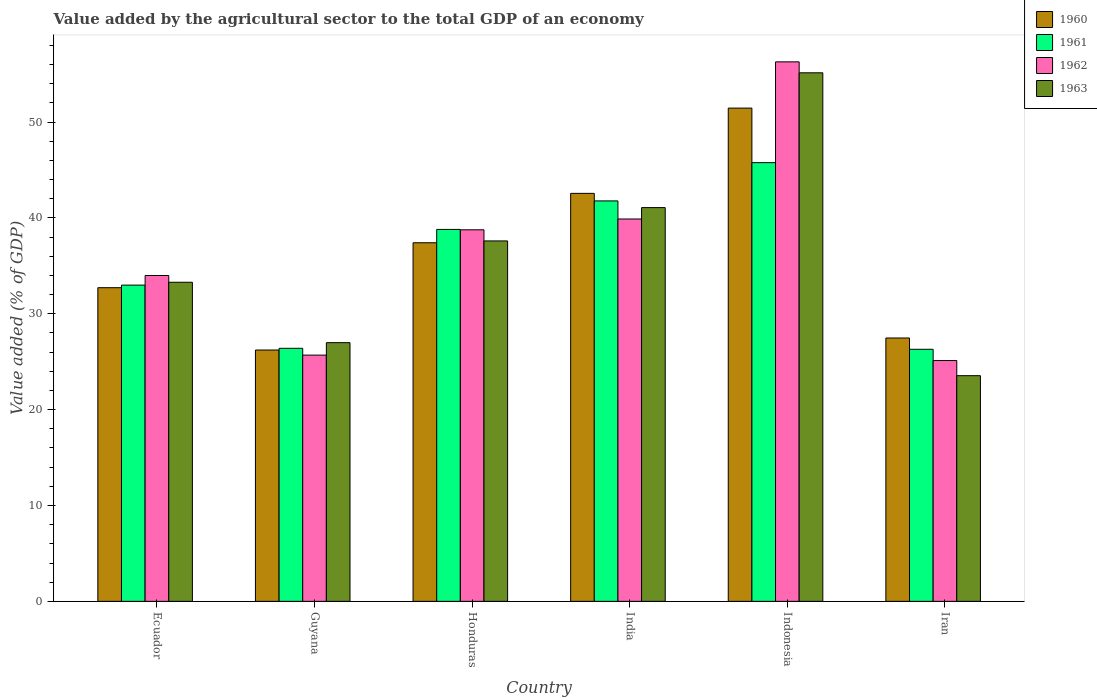How many different coloured bars are there?
Your response must be concise. 4. Are the number of bars on each tick of the X-axis equal?
Offer a terse response. Yes. How many bars are there on the 6th tick from the left?
Ensure brevity in your answer.  4. What is the label of the 3rd group of bars from the left?
Your answer should be very brief. Honduras. What is the value added by the agricultural sector to the total GDP in 1963 in India?
Provide a short and direct response. 41.08. Across all countries, what is the maximum value added by the agricultural sector to the total GDP in 1963?
Your answer should be compact. 55.14. Across all countries, what is the minimum value added by the agricultural sector to the total GDP in 1962?
Your answer should be very brief. 25.12. In which country was the value added by the agricultural sector to the total GDP in 1962 minimum?
Provide a succinct answer. Iran. What is the total value added by the agricultural sector to the total GDP in 1960 in the graph?
Keep it short and to the point. 217.84. What is the difference between the value added by the agricultural sector to the total GDP in 1962 in Guyana and that in India?
Offer a terse response. -14.2. What is the difference between the value added by the agricultural sector to the total GDP in 1960 in Indonesia and the value added by the agricultural sector to the total GDP in 1962 in Iran?
Offer a terse response. 26.34. What is the average value added by the agricultural sector to the total GDP in 1962 per country?
Make the answer very short. 36.62. What is the difference between the value added by the agricultural sector to the total GDP of/in 1961 and value added by the agricultural sector to the total GDP of/in 1960 in Ecuador?
Your answer should be compact. 0.27. What is the ratio of the value added by the agricultural sector to the total GDP in 1961 in Ecuador to that in Guyana?
Your response must be concise. 1.25. What is the difference between the highest and the second highest value added by the agricultural sector to the total GDP in 1961?
Offer a terse response. -3.99. What is the difference between the highest and the lowest value added by the agricultural sector to the total GDP in 1963?
Your response must be concise. 31.6. In how many countries, is the value added by the agricultural sector to the total GDP in 1962 greater than the average value added by the agricultural sector to the total GDP in 1962 taken over all countries?
Give a very brief answer. 3. Is it the case that in every country, the sum of the value added by the agricultural sector to the total GDP in 1960 and value added by the agricultural sector to the total GDP in 1963 is greater than the sum of value added by the agricultural sector to the total GDP in 1961 and value added by the agricultural sector to the total GDP in 1962?
Make the answer very short. No. How many bars are there?
Provide a short and direct response. 24. Are all the bars in the graph horizontal?
Your response must be concise. No. How many countries are there in the graph?
Make the answer very short. 6. What is the difference between two consecutive major ticks on the Y-axis?
Give a very brief answer. 10. Does the graph contain any zero values?
Give a very brief answer. No. Where does the legend appear in the graph?
Keep it short and to the point. Top right. What is the title of the graph?
Keep it short and to the point. Value added by the agricultural sector to the total GDP of an economy. What is the label or title of the X-axis?
Your answer should be compact. Country. What is the label or title of the Y-axis?
Provide a short and direct response. Value added (% of GDP). What is the Value added (% of GDP) in 1960 in Ecuador?
Provide a short and direct response. 32.72. What is the Value added (% of GDP) in 1961 in Ecuador?
Your answer should be very brief. 32.99. What is the Value added (% of GDP) in 1962 in Ecuador?
Offer a terse response. 33.99. What is the Value added (% of GDP) of 1963 in Ecuador?
Keep it short and to the point. 33.29. What is the Value added (% of GDP) of 1960 in Guyana?
Offer a terse response. 26.22. What is the Value added (% of GDP) in 1961 in Guyana?
Your answer should be very brief. 26.4. What is the Value added (% of GDP) of 1962 in Guyana?
Your response must be concise. 25.69. What is the Value added (% of GDP) of 1963 in Guyana?
Ensure brevity in your answer.  26.99. What is the Value added (% of GDP) in 1960 in Honduras?
Keep it short and to the point. 37.41. What is the Value added (% of GDP) of 1961 in Honduras?
Your answer should be compact. 38.8. What is the Value added (% of GDP) of 1962 in Honduras?
Provide a short and direct response. 38.76. What is the Value added (% of GDP) of 1963 in Honduras?
Your answer should be compact. 37.6. What is the Value added (% of GDP) of 1960 in India?
Make the answer very short. 42.56. What is the Value added (% of GDP) of 1961 in India?
Your answer should be very brief. 41.77. What is the Value added (% of GDP) of 1962 in India?
Ensure brevity in your answer.  39.89. What is the Value added (% of GDP) in 1963 in India?
Give a very brief answer. 41.08. What is the Value added (% of GDP) of 1960 in Indonesia?
Offer a terse response. 51.46. What is the Value added (% of GDP) of 1961 in Indonesia?
Your response must be concise. 45.77. What is the Value added (% of GDP) of 1962 in Indonesia?
Keep it short and to the point. 56.28. What is the Value added (% of GDP) of 1963 in Indonesia?
Provide a succinct answer. 55.14. What is the Value added (% of GDP) of 1960 in Iran?
Your answer should be very brief. 27.47. What is the Value added (% of GDP) of 1961 in Iran?
Ensure brevity in your answer.  26.3. What is the Value added (% of GDP) of 1962 in Iran?
Ensure brevity in your answer.  25.12. What is the Value added (% of GDP) of 1963 in Iran?
Your answer should be very brief. 23.54. Across all countries, what is the maximum Value added (% of GDP) in 1960?
Your answer should be very brief. 51.46. Across all countries, what is the maximum Value added (% of GDP) of 1961?
Provide a short and direct response. 45.77. Across all countries, what is the maximum Value added (% of GDP) in 1962?
Offer a terse response. 56.28. Across all countries, what is the maximum Value added (% of GDP) in 1963?
Provide a succinct answer. 55.14. Across all countries, what is the minimum Value added (% of GDP) of 1960?
Keep it short and to the point. 26.22. Across all countries, what is the minimum Value added (% of GDP) in 1961?
Ensure brevity in your answer.  26.3. Across all countries, what is the minimum Value added (% of GDP) in 1962?
Your response must be concise. 25.12. Across all countries, what is the minimum Value added (% of GDP) in 1963?
Offer a terse response. 23.54. What is the total Value added (% of GDP) in 1960 in the graph?
Give a very brief answer. 217.84. What is the total Value added (% of GDP) in 1961 in the graph?
Your response must be concise. 212.02. What is the total Value added (% of GDP) in 1962 in the graph?
Keep it short and to the point. 219.73. What is the total Value added (% of GDP) of 1963 in the graph?
Provide a succinct answer. 217.63. What is the difference between the Value added (% of GDP) in 1960 in Ecuador and that in Guyana?
Your answer should be very brief. 6.5. What is the difference between the Value added (% of GDP) of 1961 in Ecuador and that in Guyana?
Make the answer very short. 6.59. What is the difference between the Value added (% of GDP) in 1962 in Ecuador and that in Guyana?
Your answer should be very brief. 8.31. What is the difference between the Value added (% of GDP) in 1963 in Ecuador and that in Guyana?
Your answer should be very brief. 6.3. What is the difference between the Value added (% of GDP) in 1960 in Ecuador and that in Honduras?
Give a very brief answer. -4.69. What is the difference between the Value added (% of GDP) in 1961 in Ecuador and that in Honduras?
Provide a short and direct response. -5.81. What is the difference between the Value added (% of GDP) in 1962 in Ecuador and that in Honduras?
Give a very brief answer. -4.77. What is the difference between the Value added (% of GDP) in 1963 in Ecuador and that in Honduras?
Keep it short and to the point. -4.31. What is the difference between the Value added (% of GDP) in 1960 in Ecuador and that in India?
Offer a terse response. -9.84. What is the difference between the Value added (% of GDP) of 1961 in Ecuador and that in India?
Keep it short and to the point. -8.78. What is the difference between the Value added (% of GDP) in 1962 in Ecuador and that in India?
Your answer should be very brief. -5.89. What is the difference between the Value added (% of GDP) of 1963 in Ecuador and that in India?
Offer a very short reply. -7.79. What is the difference between the Value added (% of GDP) of 1960 in Ecuador and that in Indonesia?
Offer a very short reply. -18.74. What is the difference between the Value added (% of GDP) in 1961 in Ecuador and that in Indonesia?
Provide a succinct answer. -12.78. What is the difference between the Value added (% of GDP) in 1962 in Ecuador and that in Indonesia?
Provide a short and direct response. -22.29. What is the difference between the Value added (% of GDP) in 1963 in Ecuador and that in Indonesia?
Your response must be concise. -21.85. What is the difference between the Value added (% of GDP) of 1960 in Ecuador and that in Iran?
Ensure brevity in your answer.  5.25. What is the difference between the Value added (% of GDP) in 1961 in Ecuador and that in Iran?
Ensure brevity in your answer.  6.69. What is the difference between the Value added (% of GDP) of 1962 in Ecuador and that in Iran?
Give a very brief answer. 8.87. What is the difference between the Value added (% of GDP) in 1963 in Ecuador and that in Iran?
Your answer should be very brief. 9.74. What is the difference between the Value added (% of GDP) in 1960 in Guyana and that in Honduras?
Give a very brief answer. -11.19. What is the difference between the Value added (% of GDP) in 1961 in Guyana and that in Honduras?
Ensure brevity in your answer.  -12.4. What is the difference between the Value added (% of GDP) in 1962 in Guyana and that in Honduras?
Offer a terse response. -13.07. What is the difference between the Value added (% of GDP) of 1963 in Guyana and that in Honduras?
Ensure brevity in your answer.  -10.61. What is the difference between the Value added (% of GDP) of 1960 in Guyana and that in India?
Your response must be concise. -16.34. What is the difference between the Value added (% of GDP) in 1961 in Guyana and that in India?
Give a very brief answer. -15.38. What is the difference between the Value added (% of GDP) of 1962 in Guyana and that in India?
Your response must be concise. -14.2. What is the difference between the Value added (% of GDP) of 1963 in Guyana and that in India?
Offer a very short reply. -14.09. What is the difference between the Value added (% of GDP) of 1960 in Guyana and that in Indonesia?
Offer a terse response. -25.24. What is the difference between the Value added (% of GDP) of 1961 in Guyana and that in Indonesia?
Ensure brevity in your answer.  -19.37. What is the difference between the Value added (% of GDP) of 1962 in Guyana and that in Indonesia?
Offer a terse response. -30.59. What is the difference between the Value added (% of GDP) in 1963 in Guyana and that in Indonesia?
Give a very brief answer. -28.15. What is the difference between the Value added (% of GDP) of 1960 in Guyana and that in Iran?
Offer a very short reply. -1.25. What is the difference between the Value added (% of GDP) in 1961 in Guyana and that in Iran?
Keep it short and to the point. 0.1. What is the difference between the Value added (% of GDP) in 1962 in Guyana and that in Iran?
Provide a succinct answer. 0.57. What is the difference between the Value added (% of GDP) of 1963 in Guyana and that in Iran?
Your answer should be compact. 3.44. What is the difference between the Value added (% of GDP) of 1960 in Honduras and that in India?
Provide a short and direct response. -5.15. What is the difference between the Value added (% of GDP) in 1961 in Honduras and that in India?
Your answer should be very brief. -2.97. What is the difference between the Value added (% of GDP) in 1962 in Honduras and that in India?
Your response must be concise. -1.13. What is the difference between the Value added (% of GDP) of 1963 in Honduras and that in India?
Offer a terse response. -3.48. What is the difference between the Value added (% of GDP) in 1960 in Honduras and that in Indonesia?
Ensure brevity in your answer.  -14.05. What is the difference between the Value added (% of GDP) of 1961 in Honduras and that in Indonesia?
Your answer should be very brief. -6.96. What is the difference between the Value added (% of GDP) in 1962 in Honduras and that in Indonesia?
Keep it short and to the point. -17.52. What is the difference between the Value added (% of GDP) in 1963 in Honduras and that in Indonesia?
Offer a very short reply. -17.54. What is the difference between the Value added (% of GDP) of 1960 in Honduras and that in Iran?
Keep it short and to the point. 9.94. What is the difference between the Value added (% of GDP) in 1961 in Honduras and that in Iran?
Provide a short and direct response. 12.51. What is the difference between the Value added (% of GDP) of 1962 in Honduras and that in Iran?
Offer a very short reply. 13.64. What is the difference between the Value added (% of GDP) of 1963 in Honduras and that in Iran?
Your answer should be very brief. 14.06. What is the difference between the Value added (% of GDP) in 1960 in India and that in Indonesia?
Provide a short and direct response. -8.9. What is the difference between the Value added (% of GDP) in 1961 in India and that in Indonesia?
Give a very brief answer. -3.99. What is the difference between the Value added (% of GDP) in 1962 in India and that in Indonesia?
Make the answer very short. -16.39. What is the difference between the Value added (% of GDP) of 1963 in India and that in Indonesia?
Provide a short and direct response. -14.06. What is the difference between the Value added (% of GDP) of 1960 in India and that in Iran?
Offer a terse response. 15.09. What is the difference between the Value added (% of GDP) in 1961 in India and that in Iran?
Offer a very short reply. 15.48. What is the difference between the Value added (% of GDP) in 1962 in India and that in Iran?
Your answer should be very brief. 14.77. What is the difference between the Value added (% of GDP) in 1963 in India and that in Iran?
Your answer should be compact. 17.53. What is the difference between the Value added (% of GDP) of 1960 in Indonesia and that in Iran?
Your answer should be very brief. 23.98. What is the difference between the Value added (% of GDP) of 1961 in Indonesia and that in Iran?
Offer a very short reply. 19.47. What is the difference between the Value added (% of GDP) of 1962 in Indonesia and that in Iran?
Provide a short and direct response. 31.16. What is the difference between the Value added (% of GDP) in 1963 in Indonesia and that in Iran?
Provide a short and direct response. 31.6. What is the difference between the Value added (% of GDP) of 1960 in Ecuador and the Value added (% of GDP) of 1961 in Guyana?
Give a very brief answer. 6.32. What is the difference between the Value added (% of GDP) in 1960 in Ecuador and the Value added (% of GDP) in 1962 in Guyana?
Your response must be concise. 7.03. What is the difference between the Value added (% of GDP) of 1960 in Ecuador and the Value added (% of GDP) of 1963 in Guyana?
Your answer should be compact. 5.73. What is the difference between the Value added (% of GDP) of 1961 in Ecuador and the Value added (% of GDP) of 1962 in Guyana?
Make the answer very short. 7.3. What is the difference between the Value added (% of GDP) in 1961 in Ecuador and the Value added (% of GDP) in 1963 in Guyana?
Provide a succinct answer. 6. What is the difference between the Value added (% of GDP) of 1962 in Ecuador and the Value added (% of GDP) of 1963 in Guyana?
Your answer should be very brief. 7.01. What is the difference between the Value added (% of GDP) in 1960 in Ecuador and the Value added (% of GDP) in 1961 in Honduras?
Make the answer very short. -6.08. What is the difference between the Value added (% of GDP) of 1960 in Ecuador and the Value added (% of GDP) of 1962 in Honduras?
Provide a succinct answer. -6.04. What is the difference between the Value added (% of GDP) of 1960 in Ecuador and the Value added (% of GDP) of 1963 in Honduras?
Keep it short and to the point. -4.88. What is the difference between the Value added (% of GDP) in 1961 in Ecuador and the Value added (% of GDP) in 1962 in Honduras?
Provide a short and direct response. -5.77. What is the difference between the Value added (% of GDP) of 1961 in Ecuador and the Value added (% of GDP) of 1963 in Honduras?
Offer a terse response. -4.61. What is the difference between the Value added (% of GDP) of 1962 in Ecuador and the Value added (% of GDP) of 1963 in Honduras?
Offer a very short reply. -3.61. What is the difference between the Value added (% of GDP) of 1960 in Ecuador and the Value added (% of GDP) of 1961 in India?
Offer a very short reply. -9.05. What is the difference between the Value added (% of GDP) in 1960 in Ecuador and the Value added (% of GDP) in 1962 in India?
Offer a terse response. -7.17. What is the difference between the Value added (% of GDP) of 1960 in Ecuador and the Value added (% of GDP) of 1963 in India?
Keep it short and to the point. -8.36. What is the difference between the Value added (% of GDP) in 1961 in Ecuador and the Value added (% of GDP) in 1962 in India?
Offer a very short reply. -6.9. What is the difference between the Value added (% of GDP) of 1961 in Ecuador and the Value added (% of GDP) of 1963 in India?
Ensure brevity in your answer.  -8.09. What is the difference between the Value added (% of GDP) in 1962 in Ecuador and the Value added (% of GDP) in 1963 in India?
Your response must be concise. -7.08. What is the difference between the Value added (% of GDP) in 1960 in Ecuador and the Value added (% of GDP) in 1961 in Indonesia?
Provide a succinct answer. -13.05. What is the difference between the Value added (% of GDP) of 1960 in Ecuador and the Value added (% of GDP) of 1962 in Indonesia?
Give a very brief answer. -23.56. What is the difference between the Value added (% of GDP) in 1960 in Ecuador and the Value added (% of GDP) in 1963 in Indonesia?
Ensure brevity in your answer.  -22.42. What is the difference between the Value added (% of GDP) of 1961 in Ecuador and the Value added (% of GDP) of 1962 in Indonesia?
Your answer should be very brief. -23.29. What is the difference between the Value added (% of GDP) of 1961 in Ecuador and the Value added (% of GDP) of 1963 in Indonesia?
Make the answer very short. -22.15. What is the difference between the Value added (% of GDP) in 1962 in Ecuador and the Value added (% of GDP) in 1963 in Indonesia?
Keep it short and to the point. -21.14. What is the difference between the Value added (% of GDP) in 1960 in Ecuador and the Value added (% of GDP) in 1961 in Iran?
Your answer should be very brief. 6.43. What is the difference between the Value added (% of GDP) in 1960 in Ecuador and the Value added (% of GDP) in 1962 in Iran?
Provide a succinct answer. 7.6. What is the difference between the Value added (% of GDP) of 1960 in Ecuador and the Value added (% of GDP) of 1963 in Iran?
Give a very brief answer. 9.18. What is the difference between the Value added (% of GDP) of 1961 in Ecuador and the Value added (% of GDP) of 1962 in Iran?
Your response must be concise. 7.87. What is the difference between the Value added (% of GDP) in 1961 in Ecuador and the Value added (% of GDP) in 1963 in Iran?
Your response must be concise. 9.45. What is the difference between the Value added (% of GDP) of 1962 in Ecuador and the Value added (% of GDP) of 1963 in Iran?
Provide a short and direct response. 10.45. What is the difference between the Value added (% of GDP) in 1960 in Guyana and the Value added (% of GDP) in 1961 in Honduras?
Your response must be concise. -12.58. What is the difference between the Value added (% of GDP) of 1960 in Guyana and the Value added (% of GDP) of 1962 in Honduras?
Keep it short and to the point. -12.54. What is the difference between the Value added (% of GDP) of 1960 in Guyana and the Value added (% of GDP) of 1963 in Honduras?
Offer a very short reply. -11.38. What is the difference between the Value added (% of GDP) of 1961 in Guyana and the Value added (% of GDP) of 1962 in Honduras?
Give a very brief answer. -12.36. What is the difference between the Value added (% of GDP) in 1961 in Guyana and the Value added (% of GDP) in 1963 in Honduras?
Provide a succinct answer. -11.2. What is the difference between the Value added (% of GDP) in 1962 in Guyana and the Value added (% of GDP) in 1963 in Honduras?
Provide a short and direct response. -11.91. What is the difference between the Value added (% of GDP) of 1960 in Guyana and the Value added (% of GDP) of 1961 in India?
Offer a very short reply. -15.55. What is the difference between the Value added (% of GDP) in 1960 in Guyana and the Value added (% of GDP) in 1962 in India?
Your answer should be very brief. -13.67. What is the difference between the Value added (% of GDP) in 1960 in Guyana and the Value added (% of GDP) in 1963 in India?
Give a very brief answer. -14.86. What is the difference between the Value added (% of GDP) of 1961 in Guyana and the Value added (% of GDP) of 1962 in India?
Keep it short and to the point. -13.49. What is the difference between the Value added (% of GDP) in 1961 in Guyana and the Value added (% of GDP) in 1963 in India?
Your answer should be compact. -14.68. What is the difference between the Value added (% of GDP) of 1962 in Guyana and the Value added (% of GDP) of 1963 in India?
Provide a succinct answer. -15.39. What is the difference between the Value added (% of GDP) of 1960 in Guyana and the Value added (% of GDP) of 1961 in Indonesia?
Offer a very short reply. -19.55. What is the difference between the Value added (% of GDP) of 1960 in Guyana and the Value added (% of GDP) of 1962 in Indonesia?
Give a very brief answer. -30.06. What is the difference between the Value added (% of GDP) in 1960 in Guyana and the Value added (% of GDP) in 1963 in Indonesia?
Make the answer very short. -28.92. What is the difference between the Value added (% of GDP) of 1961 in Guyana and the Value added (% of GDP) of 1962 in Indonesia?
Your response must be concise. -29.88. What is the difference between the Value added (% of GDP) in 1961 in Guyana and the Value added (% of GDP) in 1963 in Indonesia?
Your answer should be very brief. -28.74. What is the difference between the Value added (% of GDP) in 1962 in Guyana and the Value added (% of GDP) in 1963 in Indonesia?
Provide a short and direct response. -29.45. What is the difference between the Value added (% of GDP) of 1960 in Guyana and the Value added (% of GDP) of 1961 in Iran?
Ensure brevity in your answer.  -0.08. What is the difference between the Value added (% of GDP) in 1960 in Guyana and the Value added (% of GDP) in 1962 in Iran?
Keep it short and to the point. 1.1. What is the difference between the Value added (% of GDP) in 1960 in Guyana and the Value added (% of GDP) in 1963 in Iran?
Keep it short and to the point. 2.68. What is the difference between the Value added (% of GDP) of 1961 in Guyana and the Value added (% of GDP) of 1962 in Iran?
Keep it short and to the point. 1.28. What is the difference between the Value added (% of GDP) in 1961 in Guyana and the Value added (% of GDP) in 1963 in Iran?
Keep it short and to the point. 2.85. What is the difference between the Value added (% of GDP) in 1962 in Guyana and the Value added (% of GDP) in 1963 in Iran?
Keep it short and to the point. 2.15. What is the difference between the Value added (% of GDP) in 1960 in Honduras and the Value added (% of GDP) in 1961 in India?
Your answer should be very brief. -4.36. What is the difference between the Value added (% of GDP) of 1960 in Honduras and the Value added (% of GDP) of 1962 in India?
Provide a succinct answer. -2.48. What is the difference between the Value added (% of GDP) of 1960 in Honduras and the Value added (% of GDP) of 1963 in India?
Your answer should be compact. -3.67. What is the difference between the Value added (% of GDP) of 1961 in Honduras and the Value added (% of GDP) of 1962 in India?
Your answer should be compact. -1.09. What is the difference between the Value added (% of GDP) in 1961 in Honduras and the Value added (% of GDP) in 1963 in India?
Ensure brevity in your answer.  -2.27. What is the difference between the Value added (% of GDP) in 1962 in Honduras and the Value added (% of GDP) in 1963 in India?
Your answer should be compact. -2.32. What is the difference between the Value added (% of GDP) in 1960 in Honduras and the Value added (% of GDP) in 1961 in Indonesia?
Offer a terse response. -8.36. What is the difference between the Value added (% of GDP) of 1960 in Honduras and the Value added (% of GDP) of 1962 in Indonesia?
Offer a very short reply. -18.87. What is the difference between the Value added (% of GDP) in 1960 in Honduras and the Value added (% of GDP) in 1963 in Indonesia?
Offer a very short reply. -17.73. What is the difference between the Value added (% of GDP) in 1961 in Honduras and the Value added (% of GDP) in 1962 in Indonesia?
Your answer should be compact. -17.48. What is the difference between the Value added (% of GDP) in 1961 in Honduras and the Value added (% of GDP) in 1963 in Indonesia?
Make the answer very short. -16.34. What is the difference between the Value added (% of GDP) of 1962 in Honduras and the Value added (% of GDP) of 1963 in Indonesia?
Offer a terse response. -16.38. What is the difference between the Value added (% of GDP) of 1960 in Honduras and the Value added (% of GDP) of 1961 in Iran?
Make the answer very short. 11.11. What is the difference between the Value added (% of GDP) in 1960 in Honduras and the Value added (% of GDP) in 1962 in Iran?
Make the answer very short. 12.29. What is the difference between the Value added (% of GDP) in 1960 in Honduras and the Value added (% of GDP) in 1963 in Iran?
Your response must be concise. 13.87. What is the difference between the Value added (% of GDP) in 1961 in Honduras and the Value added (% of GDP) in 1962 in Iran?
Keep it short and to the point. 13.68. What is the difference between the Value added (% of GDP) of 1961 in Honduras and the Value added (% of GDP) of 1963 in Iran?
Ensure brevity in your answer.  15.26. What is the difference between the Value added (% of GDP) in 1962 in Honduras and the Value added (% of GDP) in 1963 in Iran?
Offer a very short reply. 15.22. What is the difference between the Value added (% of GDP) in 1960 in India and the Value added (% of GDP) in 1961 in Indonesia?
Make the answer very short. -3.21. What is the difference between the Value added (% of GDP) of 1960 in India and the Value added (% of GDP) of 1962 in Indonesia?
Give a very brief answer. -13.72. What is the difference between the Value added (% of GDP) of 1960 in India and the Value added (% of GDP) of 1963 in Indonesia?
Your answer should be very brief. -12.58. What is the difference between the Value added (% of GDP) of 1961 in India and the Value added (% of GDP) of 1962 in Indonesia?
Offer a terse response. -14.51. What is the difference between the Value added (% of GDP) of 1961 in India and the Value added (% of GDP) of 1963 in Indonesia?
Ensure brevity in your answer.  -13.36. What is the difference between the Value added (% of GDP) of 1962 in India and the Value added (% of GDP) of 1963 in Indonesia?
Your answer should be compact. -15.25. What is the difference between the Value added (% of GDP) of 1960 in India and the Value added (% of GDP) of 1961 in Iran?
Your answer should be compact. 16.27. What is the difference between the Value added (% of GDP) in 1960 in India and the Value added (% of GDP) in 1962 in Iran?
Provide a succinct answer. 17.44. What is the difference between the Value added (% of GDP) in 1960 in India and the Value added (% of GDP) in 1963 in Iran?
Your response must be concise. 19.02. What is the difference between the Value added (% of GDP) in 1961 in India and the Value added (% of GDP) in 1962 in Iran?
Keep it short and to the point. 16.65. What is the difference between the Value added (% of GDP) of 1961 in India and the Value added (% of GDP) of 1963 in Iran?
Offer a terse response. 18.23. What is the difference between the Value added (% of GDP) of 1962 in India and the Value added (% of GDP) of 1963 in Iran?
Your response must be concise. 16.35. What is the difference between the Value added (% of GDP) of 1960 in Indonesia and the Value added (% of GDP) of 1961 in Iran?
Make the answer very short. 25.16. What is the difference between the Value added (% of GDP) of 1960 in Indonesia and the Value added (% of GDP) of 1962 in Iran?
Give a very brief answer. 26.34. What is the difference between the Value added (% of GDP) in 1960 in Indonesia and the Value added (% of GDP) in 1963 in Iran?
Make the answer very short. 27.91. What is the difference between the Value added (% of GDP) in 1961 in Indonesia and the Value added (% of GDP) in 1962 in Iran?
Ensure brevity in your answer.  20.65. What is the difference between the Value added (% of GDP) in 1961 in Indonesia and the Value added (% of GDP) in 1963 in Iran?
Offer a terse response. 22.22. What is the difference between the Value added (% of GDP) of 1962 in Indonesia and the Value added (% of GDP) of 1963 in Iran?
Ensure brevity in your answer.  32.74. What is the average Value added (% of GDP) in 1960 per country?
Your answer should be compact. 36.31. What is the average Value added (% of GDP) of 1961 per country?
Your answer should be compact. 35.34. What is the average Value added (% of GDP) in 1962 per country?
Your answer should be compact. 36.62. What is the average Value added (% of GDP) in 1963 per country?
Provide a short and direct response. 36.27. What is the difference between the Value added (% of GDP) of 1960 and Value added (% of GDP) of 1961 in Ecuador?
Provide a short and direct response. -0.27. What is the difference between the Value added (% of GDP) of 1960 and Value added (% of GDP) of 1962 in Ecuador?
Offer a very short reply. -1.27. What is the difference between the Value added (% of GDP) of 1960 and Value added (% of GDP) of 1963 in Ecuador?
Ensure brevity in your answer.  -0.57. What is the difference between the Value added (% of GDP) in 1961 and Value added (% of GDP) in 1962 in Ecuador?
Offer a terse response. -1. What is the difference between the Value added (% of GDP) of 1961 and Value added (% of GDP) of 1963 in Ecuador?
Ensure brevity in your answer.  -0.3. What is the difference between the Value added (% of GDP) in 1962 and Value added (% of GDP) in 1963 in Ecuador?
Offer a very short reply. 0.71. What is the difference between the Value added (% of GDP) in 1960 and Value added (% of GDP) in 1961 in Guyana?
Offer a very short reply. -0.18. What is the difference between the Value added (% of GDP) of 1960 and Value added (% of GDP) of 1962 in Guyana?
Your response must be concise. 0.53. What is the difference between the Value added (% of GDP) of 1960 and Value added (% of GDP) of 1963 in Guyana?
Your response must be concise. -0.77. What is the difference between the Value added (% of GDP) in 1961 and Value added (% of GDP) in 1962 in Guyana?
Ensure brevity in your answer.  0.71. What is the difference between the Value added (% of GDP) of 1961 and Value added (% of GDP) of 1963 in Guyana?
Provide a succinct answer. -0.59. What is the difference between the Value added (% of GDP) of 1962 and Value added (% of GDP) of 1963 in Guyana?
Provide a short and direct response. -1.3. What is the difference between the Value added (% of GDP) in 1960 and Value added (% of GDP) in 1961 in Honduras?
Your answer should be very brief. -1.39. What is the difference between the Value added (% of GDP) in 1960 and Value added (% of GDP) in 1962 in Honduras?
Your answer should be compact. -1.35. What is the difference between the Value added (% of GDP) of 1960 and Value added (% of GDP) of 1963 in Honduras?
Ensure brevity in your answer.  -0.19. What is the difference between the Value added (% of GDP) of 1961 and Value added (% of GDP) of 1962 in Honduras?
Provide a short and direct response. 0.04. What is the difference between the Value added (% of GDP) of 1961 and Value added (% of GDP) of 1963 in Honduras?
Provide a succinct answer. 1.2. What is the difference between the Value added (% of GDP) of 1962 and Value added (% of GDP) of 1963 in Honduras?
Make the answer very short. 1.16. What is the difference between the Value added (% of GDP) of 1960 and Value added (% of GDP) of 1961 in India?
Give a very brief answer. 0.79. What is the difference between the Value added (% of GDP) of 1960 and Value added (% of GDP) of 1962 in India?
Your answer should be very brief. 2.67. What is the difference between the Value added (% of GDP) in 1960 and Value added (% of GDP) in 1963 in India?
Your answer should be very brief. 1.49. What is the difference between the Value added (% of GDP) of 1961 and Value added (% of GDP) of 1962 in India?
Your response must be concise. 1.89. What is the difference between the Value added (% of GDP) of 1961 and Value added (% of GDP) of 1963 in India?
Keep it short and to the point. 0.7. What is the difference between the Value added (% of GDP) in 1962 and Value added (% of GDP) in 1963 in India?
Your response must be concise. -1.19. What is the difference between the Value added (% of GDP) of 1960 and Value added (% of GDP) of 1961 in Indonesia?
Ensure brevity in your answer.  5.69. What is the difference between the Value added (% of GDP) of 1960 and Value added (% of GDP) of 1962 in Indonesia?
Your answer should be compact. -4.82. What is the difference between the Value added (% of GDP) in 1960 and Value added (% of GDP) in 1963 in Indonesia?
Offer a terse response. -3.68. What is the difference between the Value added (% of GDP) of 1961 and Value added (% of GDP) of 1962 in Indonesia?
Your answer should be very brief. -10.51. What is the difference between the Value added (% of GDP) of 1961 and Value added (% of GDP) of 1963 in Indonesia?
Give a very brief answer. -9.37. What is the difference between the Value added (% of GDP) of 1962 and Value added (% of GDP) of 1963 in Indonesia?
Your answer should be very brief. 1.14. What is the difference between the Value added (% of GDP) of 1960 and Value added (% of GDP) of 1961 in Iran?
Provide a short and direct response. 1.18. What is the difference between the Value added (% of GDP) in 1960 and Value added (% of GDP) in 1962 in Iran?
Ensure brevity in your answer.  2.35. What is the difference between the Value added (% of GDP) of 1960 and Value added (% of GDP) of 1963 in Iran?
Offer a very short reply. 3.93. What is the difference between the Value added (% of GDP) in 1961 and Value added (% of GDP) in 1962 in Iran?
Keep it short and to the point. 1.17. What is the difference between the Value added (% of GDP) of 1961 and Value added (% of GDP) of 1963 in Iran?
Your answer should be compact. 2.75. What is the difference between the Value added (% of GDP) in 1962 and Value added (% of GDP) in 1963 in Iran?
Offer a very short reply. 1.58. What is the ratio of the Value added (% of GDP) of 1960 in Ecuador to that in Guyana?
Keep it short and to the point. 1.25. What is the ratio of the Value added (% of GDP) of 1961 in Ecuador to that in Guyana?
Ensure brevity in your answer.  1.25. What is the ratio of the Value added (% of GDP) in 1962 in Ecuador to that in Guyana?
Offer a terse response. 1.32. What is the ratio of the Value added (% of GDP) of 1963 in Ecuador to that in Guyana?
Provide a succinct answer. 1.23. What is the ratio of the Value added (% of GDP) in 1960 in Ecuador to that in Honduras?
Make the answer very short. 0.87. What is the ratio of the Value added (% of GDP) in 1961 in Ecuador to that in Honduras?
Provide a succinct answer. 0.85. What is the ratio of the Value added (% of GDP) of 1962 in Ecuador to that in Honduras?
Provide a short and direct response. 0.88. What is the ratio of the Value added (% of GDP) of 1963 in Ecuador to that in Honduras?
Your response must be concise. 0.89. What is the ratio of the Value added (% of GDP) of 1960 in Ecuador to that in India?
Keep it short and to the point. 0.77. What is the ratio of the Value added (% of GDP) of 1961 in Ecuador to that in India?
Ensure brevity in your answer.  0.79. What is the ratio of the Value added (% of GDP) of 1962 in Ecuador to that in India?
Your answer should be compact. 0.85. What is the ratio of the Value added (% of GDP) of 1963 in Ecuador to that in India?
Give a very brief answer. 0.81. What is the ratio of the Value added (% of GDP) of 1960 in Ecuador to that in Indonesia?
Your response must be concise. 0.64. What is the ratio of the Value added (% of GDP) of 1961 in Ecuador to that in Indonesia?
Provide a short and direct response. 0.72. What is the ratio of the Value added (% of GDP) of 1962 in Ecuador to that in Indonesia?
Provide a short and direct response. 0.6. What is the ratio of the Value added (% of GDP) in 1963 in Ecuador to that in Indonesia?
Keep it short and to the point. 0.6. What is the ratio of the Value added (% of GDP) in 1960 in Ecuador to that in Iran?
Give a very brief answer. 1.19. What is the ratio of the Value added (% of GDP) of 1961 in Ecuador to that in Iran?
Ensure brevity in your answer.  1.25. What is the ratio of the Value added (% of GDP) of 1962 in Ecuador to that in Iran?
Offer a terse response. 1.35. What is the ratio of the Value added (% of GDP) of 1963 in Ecuador to that in Iran?
Offer a terse response. 1.41. What is the ratio of the Value added (% of GDP) of 1960 in Guyana to that in Honduras?
Your answer should be very brief. 0.7. What is the ratio of the Value added (% of GDP) of 1961 in Guyana to that in Honduras?
Your answer should be very brief. 0.68. What is the ratio of the Value added (% of GDP) in 1962 in Guyana to that in Honduras?
Make the answer very short. 0.66. What is the ratio of the Value added (% of GDP) of 1963 in Guyana to that in Honduras?
Your answer should be compact. 0.72. What is the ratio of the Value added (% of GDP) in 1960 in Guyana to that in India?
Give a very brief answer. 0.62. What is the ratio of the Value added (% of GDP) in 1961 in Guyana to that in India?
Give a very brief answer. 0.63. What is the ratio of the Value added (% of GDP) in 1962 in Guyana to that in India?
Give a very brief answer. 0.64. What is the ratio of the Value added (% of GDP) of 1963 in Guyana to that in India?
Make the answer very short. 0.66. What is the ratio of the Value added (% of GDP) in 1960 in Guyana to that in Indonesia?
Provide a short and direct response. 0.51. What is the ratio of the Value added (% of GDP) in 1961 in Guyana to that in Indonesia?
Your answer should be very brief. 0.58. What is the ratio of the Value added (% of GDP) of 1962 in Guyana to that in Indonesia?
Make the answer very short. 0.46. What is the ratio of the Value added (% of GDP) in 1963 in Guyana to that in Indonesia?
Keep it short and to the point. 0.49. What is the ratio of the Value added (% of GDP) of 1960 in Guyana to that in Iran?
Make the answer very short. 0.95. What is the ratio of the Value added (% of GDP) of 1962 in Guyana to that in Iran?
Provide a short and direct response. 1.02. What is the ratio of the Value added (% of GDP) in 1963 in Guyana to that in Iran?
Give a very brief answer. 1.15. What is the ratio of the Value added (% of GDP) in 1960 in Honduras to that in India?
Your response must be concise. 0.88. What is the ratio of the Value added (% of GDP) in 1961 in Honduras to that in India?
Offer a terse response. 0.93. What is the ratio of the Value added (% of GDP) in 1962 in Honduras to that in India?
Offer a very short reply. 0.97. What is the ratio of the Value added (% of GDP) of 1963 in Honduras to that in India?
Your response must be concise. 0.92. What is the ratio of the Value added (% of GDP) in 1960 in Honduras to that in Indonesia?
Ensure brevity in your answer.  0.73. What is the ratio of the Value added (% of GDP) of 1961 in Honduras to that in Indonesia?
Provide a short and direct response. 0.85. What is the ratio of the Value added (% of GDP) of 1962 in Honduras to that in Indonesia?
Your response must be concise. 0.69. What is the ratio of the Value added (% of GDP) in 1963 in Honduras to that in Indonesia?
Provide a succinct answer. 0.68. What is the ratio of the Value added (% of GDP) in 1960 in Honduras to that in Iran?
Offer a terse response. 1.36. What is the ratio of the Value added (% of GDP) in 1961 in Honduras to that in Iran?
Offer a very short reply. 1.48. What is the ratio of the Value added (% of GDP) in 1962 in Honduras to that in Iran?
Offer a terse response. 1.54. What is the ratio of the Value added (% of GDP) of 1963 in Honduras to that in Iran?
Keep it short and to the point. 1.6. What is the ratio of the Value added (% of GDP) in 1960 in India to that in Indonesia?
Keep it short and to the point. 0.83. What is the ratio of the Value added (% of GDP) in 1961 in India to that in Indonesia?
Your response must be concise. 0.91. What is the ratio of the Value added (% of GDP) of 1962 in India to that in Indonesia?
Ensure brevity in your answer.  0.71. What is the ratio of the Value added (% of GDP) in 1963 in India to that in Indonesia?
Keep it short and to the point. 0.74. What is the ratio of the Value added (% of GDP) of 1960 in India to that in Iran?
Make the answer very short. 1.55. What is the ratio of the Value added (% of GDP) of 1961 in India to that in Iran?
Offer a very short reply. 1.59. What is the ratio of the Value added (% of GDP) in 1962 in India to that in Iran?
Ensure brevity in your answer.  1.59. What is the ratio of the Value added (% of GDP) in 1963 in India to that in Iran?
Keep it short and to the point. 1.74. What is the ratio of the Value added (% of GDP) in 1960 in Indonesia to that in Iran?
Offer a terse response. 1.87. What is the ratio of the Value added (% of GDP) in 1961 in Indonesia to that in Iran?
Offer a terse response. 1.74. What is the ratio of the Value added (% of GDP) of 1962 in Indonesia to that in Iran?
Offer a terse response. 2.24. What is the ratio of the Value added (% of GDP) in 1963 in Indonesia to that in Iran?
Keep it short and to the point. 2.34. What is the difference between the highest and the second highest Value added (% of GDP) of 1960?
Your answer should be compact. 8.9. What is the difference between the highest and the second highest Value added (% of GDP) in 1961?
Keep it short and to the point. 3.99. What is the difference between the highest and the second highest Value added (% of GDP) in 1962?
Give a very brief answer. 16.39. What is the difference between the highest and the second highest Value added (% of GDP) of 1963?
Ensure brevity in your answer.  14.06. What is the difference between the highest and the lowest Value added (% of GDP) of 1960?
Ensure brevity in your answer.  25.24. What is the difference between the highest and the lowest Value added (% of GDP) of 1961?
Ensure brevity in your answer.  19.47. What is the difference between the highest and the lowest Value added (% of GDP) of 1962?
Offer a terse response. 31.16. What is the difference between the highest and the lowest Value added (% of GDP) in 1963?
Make the answer very short. 31.6. 